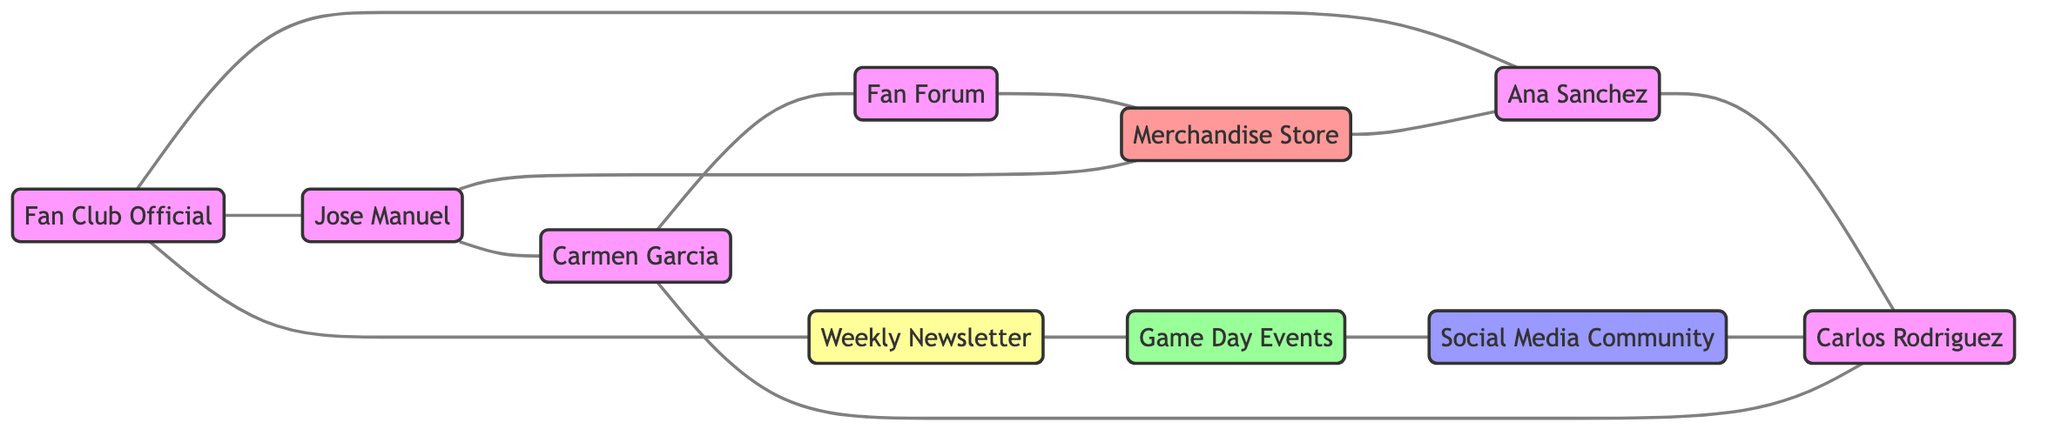What is the total number of nodes in the diagram? The diagram includes a list of entities or participants, which are "Fan Club Official," "Jose Manuel," "Ana Sanchez," "Weekly Newsletter," "Game Day Events," "Social Media Community," "Carlos Rodriguez," "Carmen Garcia," "Fan Forum," and "Merchandise Store." Counting these nodes gives us a total of ten.
Answer: 10 Which two nodes are directly connected to "Fan Club Official"? By examining the edges originating from "Fan Club Official," we see that it connects directly to "Jose Manuel" and "Ana Sanchez." Thus, the answer is based on the direct connections shown in the diagram.
Answer: Jose Manuel, Ana Sanchez What is the relationship between "Game Day Events" and "Social Media Community"? "Game Day Events" and "Social Media Community" share a direct connection as indicated by the edge between them. This relationship signifies that they are linked within the fan engagement context.
Answer: Directly connected How many edges connect to "Carlos Rodriguez"? Counting the connections from "Carlos Rodriguez" to other nodes, we find that it has edges connecting it to "Ana Sanchez," "Carmen Garcia," and "Social Media Community." Summing these gives us a total of three edges connected to "Carlos Rodriguez."
Answer: 3 What role does "Weekly Newsletter" play in the engagement network? "Weekly Newsletter" is connected to both "Fan Club Official" and "Game Day Events," indicating that it serves as an important flow of information within this network, enhancing engagement during events. Thus, its role is that of an information dissemination point.
Answer: Information dissemination Which node connects "Carmen Garcia" to "Merchandise Store"? "Carmen Garcia" is directly connected to "Fan Forum," while "Fan Forum" in turn connects to "Merchandise Store." Hence, "Fan Forum" serves as the connecting node between "Carmen Garcia" and "Merchandise Store."
Answer: Fan Forum What is the shortest path from "Social Media Community" to "Jose Manuel"? Tracing the connections, the shortest path is from "Social Media Community" to "Carlos Rodriguez," then to "Ana Sanchez," and finally to "Jose Manuel.” This involves three edges traversed which is the least number of connections required.
Answer: 3 How many times does "Merchandise Store" appear as a connecting node? Observing the edges, "Merchandise Store" acts as a connecting node twice, linking back to both "Jose Manuel" and "Ana Sanchez." Therefore, we can conclude that it is a vital point of engagement.
Answer: 2 Which fan interacted with the "Fan Forum"? "Carmen Garcia" is the fan who has a direct connection to the "Fan Forum" as shown in the diagram. This indicates her involvement in this specific area of fan engagement.
Answer: Carmen Garcia 